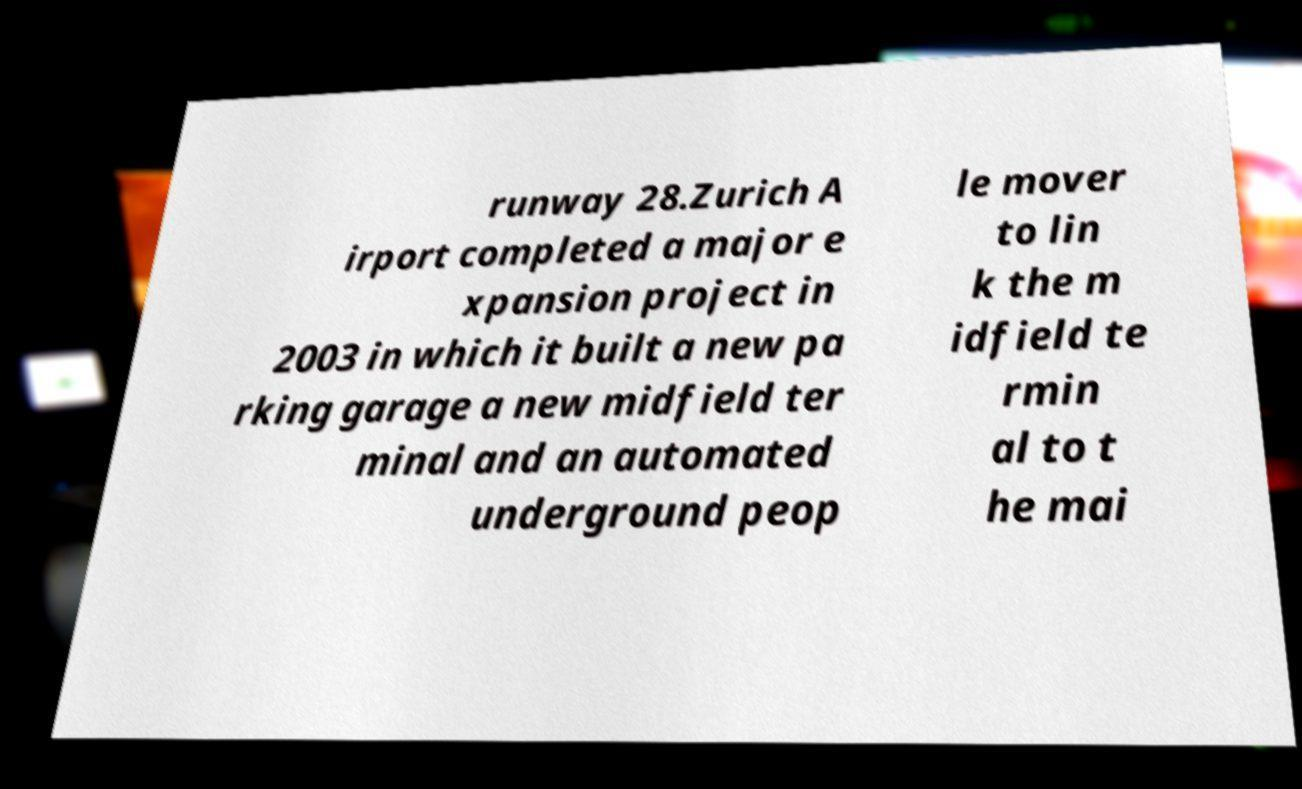Can you accurately transcribe the text from the provided image for me? runway 28.Zurich A irport completed a major e xpansion project in 2003 in which it built a new pa rking garage a new midfield ter minal and an automated underground peop le mover to lin k the m idfield te rmin al to t he mai 